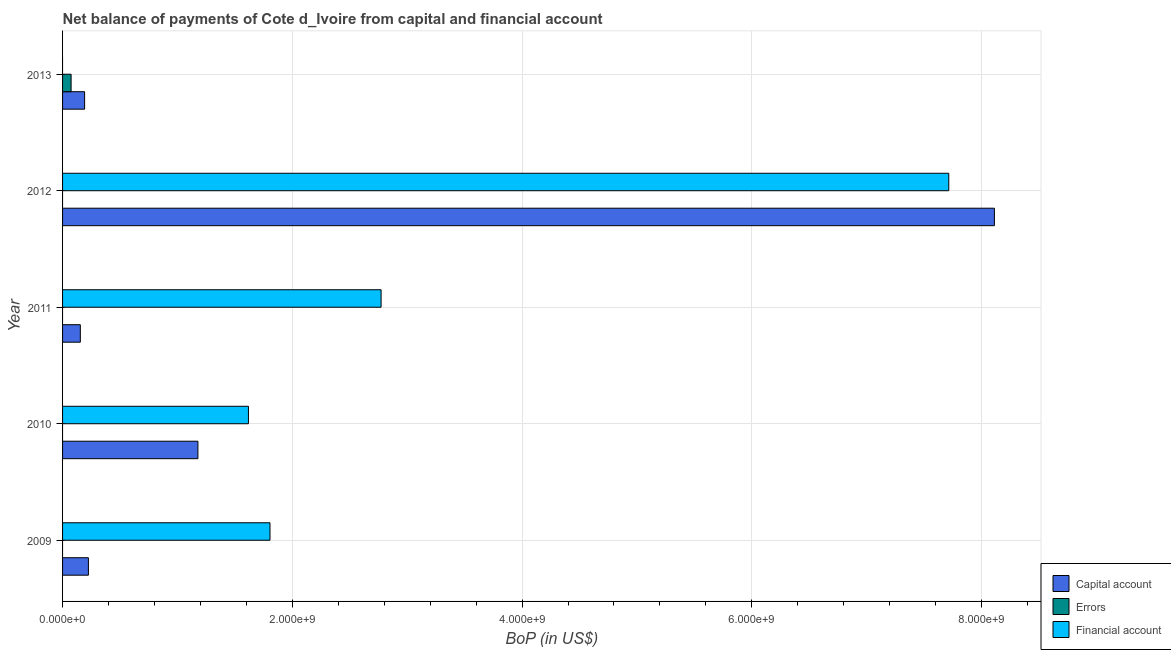How many bars are there on the 1st tick from the top?
Give a very brief answer. 2. What is the label of the 4th group of bars from the top?
Your answer should be compact. 2010. In how many cases, is the number of bars for a given year not equal to the number of legend labels?
Your answer should be compact. 5. What is the amount of financial account in 2009?
Your answer should be compact. 1.81e+09. Across all years, what is the maximum amount of net capital account?
Make the answer very short. 8.11e+09. Across all years, what is the minimum amount of net capital account?
Offer a terse response. 1.55e+08. In which year was the amount of net capital account maximum?
Provide a succinct answer. 2012. What is the total amount of errors in the graph?
Provide a succinct answer. 7.43e+07. What is the difference between the amount of net capital account in 2010 and that in 2011?
Offer a terse response. 1.02e+09. What is the difference between the amount of errors in 2011 and the amount of financial account in 2009?
Offer a very short reply. -1.81e+09. What is the average amount of financial account per year?
Provide a short and direct response. 2.78e+09. In the year 2012, what is the difference between the amount of net capital account and amount of financial account?
Offer a terse response. 3.97e+08. What is the ratio of the amount of net capital account in 2009 to that in 2010?
Provide a succinct answer. 0.19. Is the difference between the amount of net capital account in 2010 and 2011 greater than the difference between the amount of financial account in 2010 and 2011?
Offer a terse response. Yes. What is the difference between the highest and the second highest amount of financial account?
Keep it short and to the point. 4.94e+09. What is the difference between the highest and the lowest amount of net capital account?
Ensure brevity in your answer.  7.96e+09. Is the sum of the amount of net capital account in 2009 and 2013 greater than the maximum amount of errors across all years?
Offer a very short reply. Yes. Is it the case that in every year, the sum of the amount of net capital account and amount of errors is greater than the amount of financial account?
Offer a very short reply. No. How many bars are there?
Make the answer very short. 10. What is the difference between two consecutive major ticks on the X-axis?
Provide a succinct answer. 2.00e+09. Are the values on the major ticks of X-axis written in scientific E-notation?
Offer a very short reply. Yes. Does the graph contain grids?
Provide a succinct answer. Yes. How many legend labels are there?
Offer a terse response. 3. What is the title of the graph?
Give a very brief answer. Net balance of payments of Cote d_Ivoire from capital and financial account. Does "Interest" appear as one of the legend labels in the graph?
Offer a very short reply. No. What is the label or title of the X-axis?
Provide a succinct answer. BoP (in US$). What is the label or title of the Y-axis?
Offer a terse response. Year. What is the BoP (in US$) in Capital account in 2009?
Provide a short and direct response. 2.25e+08. What is the BoP (in US$) of Errors in 2009?
Give a very brief answer. 0. What is the BoP (in US$) of Financial account in 2009?
Your answer should be very brief. 1.81e+09. What is the BoP (in US$) of Capital account in 2010?
Give a very brief answer. 1.18e+09. What is the BoP (in US$) of Financial account in 2010?
Provide a short and direct response. 1.62e+09. What is the BoP (in US$) in Capital account in 2011?
Give a very brief answer. 1.55e+08. What is the BoP (in US$) in Errors in 2011?
Your answer should be compact. 0. What is the BoP (in US$) in Financial account in 2011?
Ensure brevity in your answer.  2.77e+09. What is the BoP (in US$) of Capital account in 2012?
Your response must be concise. 8.11e+09. What is the BoP (in US$) in Financial account in 2012?
Provide a short and direct response. 7.71e+09. What is the BoP (in US$) of Capital account in 2013?
Your answer should be compact. 1.92e+08. What is the BoP (in US$) in Errors in 2013?
Make the answer very short. 7.43e+07. What is the BoP (in US$) of Financial account in 2013?
Provide a short and direct response. 0. Across all years, what is the maximum BoP (in US$) of Capital account?
Provide a succinct answer. 8.11e+09. Across all years, what is the maximum BoP (in US$) in Errors?
Ensure brevity in your answer.  7.43e+07. Across all years, what is the maximum BoP (in US$) in Financial account?
Offer a terse response. 7.71e+09. Across all years, what is the minimum BoP (in US$) in Capital account?
Give a very brief answer. 1.55e+08. Across all years, what is the minimum BoP (in US$) in Financial account?
Your answer should be very brief. 0. What is the total BoP (in US$) in Capital account in the graph?
Provide a succinct answer. 9.86e+09. What is the total BoP (in US$) of Errors in the graph?
Your response must be concise. 7.43e+07. What is the total BoP (in US$) in Financial account in the graph?
Keep it short and to the point. 1.39e+1. What is the difference between the BoP (in US$) of Capital account in 2009 and that in 2010?
Give a very brief answer. -9.53e+08. What is the difference between the BoP (in US$) of Financial account in 2009 and that in 2010?
Your answer should be very brief. 1.88e+08. What is the difference between the BoP (in US$) of Capital account in 2009 and that in 2011?
Keep it short and to the point. 7.03e+07. What is the difference between the BoP (in US$) of Financial account in 2009 and that in 2011?
Offer a terse response. -9.67e+08. What is the difference between the BoP (in US$) of Capital account in 2009 and that in 2012?
Offer a very short reply. -7.89e+09. What is the difference between the BoP (in US$) of Financial account in 2009 and that in 2012?
Make the answer very short. -5.91e+09. What is the difference between the BoP (in US$) in Capital account in 2009 and that in 2013?
Give a very brief answer. 3.31e+07. What is the difference between the BoP (in US$) in Capital account in 2010 and that in 2011?
Give a very brief answer. 1.02e+09. What is the difference between the BoP (in US$) in Financial account in 2010 and that in 2011?
Ensure brevity in your answer.  -1.15e+09. What is the difference between the BoP (in US$) in Capital account in 2010 and that in 2012?
Provide a short and direct response. -6.93e+09. What is the difference between the BoP (in US$) in Financial account in 2010 and that in 2012?
Your response must be concise. -6.10e+09. What is the difference between the BoP (in US$) of Capital account in 2010 and that in 2013?
Offer a very short reply. 9.86e+08. What is the difference between the BoP (in US$) in Capital account in 2011 and that in 2012?
Your answer should be compact. -7.96e+09. What is the difference between the BoP (in US$) of Financial account in 2011 and that in 2012?
Make the answer very short. -4.94e+09. What is the difference between the BoP (in US$) in Capital account in 2011 and that in 2013?
Offer a very short reply. -3.72e+07. What is the difference between the BoP (in US$) of Capital account in 2012 and that in 2013?
Give a very brief answer. 7.92e+09. What is the difference between the BoP (in US$) of Capital account in 2009 and the BoP (in US$) of Financial account in 2010?
Offer a terse response. -1.39e+09. What is the difference between the BoP (in US$) in Capital account in 2009 and the BoP (in US$) in Financial account in 2011?
Your answer should be compact. -2.55e+09. What is the difference between the BoP (in US$) in Capital account in 2009 and the BoP (in US$) in Financial account in 2012?
Give a very brief answer. -7.49e+09. What is the difference between the BoP (in US$) in Capital account in 2009 and the BoP (in US$) in Errors in 2013?
Give a very brief answer. 1.51e+08. What is the difference between the BoP (in US$) of Capital account in 2010 and the BoP (in US$) of Financial account in 2011?
Your response must be concise. -1.59e+09. What is the difference between the BoP (in US$) in Capital account in 2010 and the BoP (in US$) in Financial account in 2012?
Your answer should be very brief. -6.54e+09. What is the difference between the BoP (in US$) in Capital account in 2010 and the BoP (in US$) in Errors in 2013?
Provide a succinct answer. 1.10e+09. What is the difference between the BoP (in US$) in Capital account in 2011 and the BoP (in US$) in Financial account in 2012?
Your answer should be very brief. -7.56e+09. What is the difference between the BoP (in US$) of Capital account in 2011 and the BoP (in US$) of Errors in 2013?
Make the answer very short. 8.04e+07. What is the difference between the BoP (in US$) in Capital account in 2012 and the BoP (in US$) in Errors in 2013?
Provide a succinct answer. 8.04e+09. What is the average BoP (in US$) in Capital account per year?
Provide a short and direct response. 1.97e+09. What is the average BoP (in US$) in Errors per year?
Offer a terse response. 1.49e+07. What is the average BoP (in US$) in Financial account per year?
Keep it short and to the point. 2.78e+09. In the year 2009, what is the difference between the BoP (in US$) of Capital account and BoP (in US$) of Financial account?
Keep it short and to the point. -1.58e+09. In the year 2010, what is the difference between the BoP (in US$) of Capital account and BoP (in US$) of Financial account?
Offer a very short reply. -4.40e+08. In the year 2011, what is the difference between the BoP (in US$) in Capital account and BoP (in US$) in Financial account?
Give a very brief answer. -2.62e+09. In the year 2012, what is the difference between the BoP (in US$) of Capital account and BoP (in US$) of Financial account?
Make the answer very short. 3.97e+08. In the year 2013, what is the difference between the BoP (in US$) of Capital account and BoP (in US$) of Errors?
Ensure brevity in your answer.  1.18e+08. What is the ratio of the BoP (in US$) of Capital account in 2009 to that in 2010?
Keep it short and to the point. 0.19. What is the ratio of the BoP (in US$) of Financial account in 2009 to that in 2010?
Keep it short and to the point. 1.12. What is the ratio of the BoP (in US$) in Capital account in 2009 to that in 2011?
Make the answer very short. 1.45. What is the ratio of the BoP (in US$) of Financial account in 2009 to that in 2011?
Give a very brief answer. 0.65. What is the ratio of the BoP (in US$) in Capital account in 2009 to that in 2012?
Provide a succinct answer. 0.03. What is the ratio of the BoP (in US$) in Financial account in 2009 to that in 2012?
Make the answer very short. 0.23. What is the ratio of the BoP (in US$) in Capital account in 2009 to that in 2013?
Offer a very short reply. 1.17. What is the ratio of the BoP (in US$) of Capital account in 2010 to that in 2011?
Keep it short and to the point. 7.62. What is the ratio of the BoP (in US$) in Financial account in 2010 to that in 2011?
Provide a succinct answer. 0.58. What is the ratio of the BoP (in US$) in Capital account in 2010 to that in 2012?
Your response must be concise. 0.15. What is the ratio of the BoP (in US$) of Financial account in 2010 to that in 2012?
Ensure brevity in your answer.  0.21. What is the ratio of the BoP (in US$) in Capital account in 2010 to that in 2013?
Ensure brevity in your answer.  6.14. What is the ratio of the BoP (in US$) of Capital account in 2011 to that in 2012?
Offer a terse response. 0.02. What is the ratio of the BoP (in US$) of Financial account in 2011 to that in 2012?
Provide a succinct answer. 0.36. What is the ratio of the BoP (in US$) in Capital account in 2011 to that in 2013?
Your response must be concise. 0.81. What is the ratio of the BoP (in US$) of Capital account in 2012 to that in 2013?
Offer a terse response. 42.28. What is the difference between the highest and the second highest BoP (in US$) of Capital account?
Provide a succinct answer. 6.93e+09. What is the difference between the highest and the second highest BoP (in US$) in Financial account?
Give a very brief answer. 4.94e+09. What is the difference between the highest and the lowest BoP (in US$) in Capital account?
Keep it short and to the point. 7.96e+09. What is the difference between the highest and the lowest BoP (in US$) in Errors?
Provide a short and direct response. 7.43e+07. What is the difference between the highest and the lowest BoP (in US$) of Financial account?
Provide a succinct answer. 7.71e+09. 